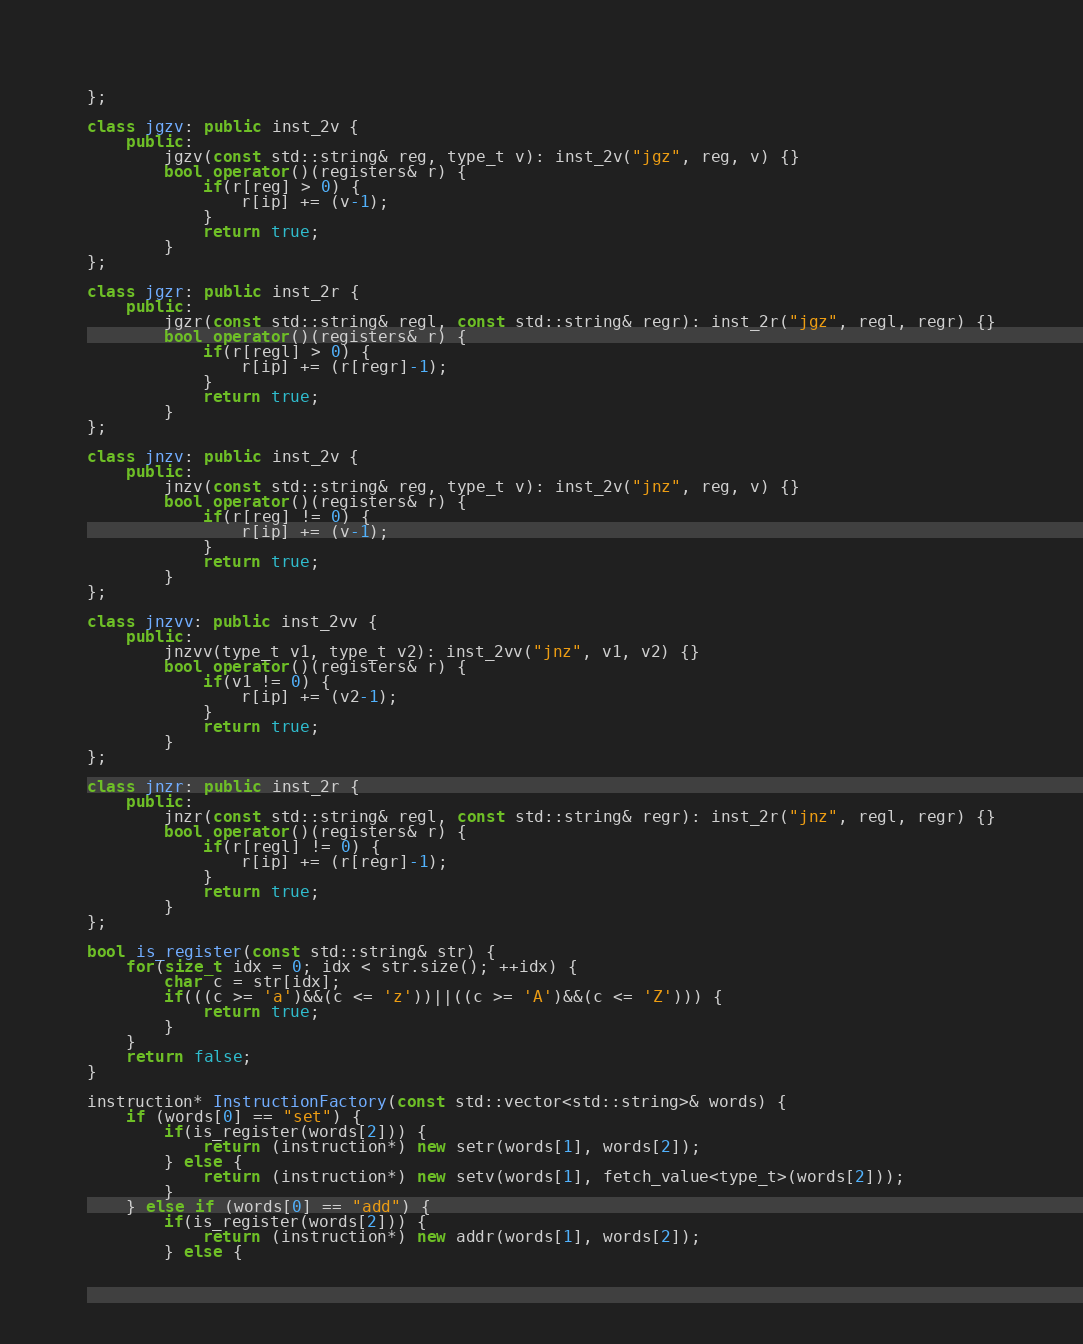Convert code to text. <code><loc_0><loc_0><loc_500><loc_500><_C++_>};

class jgzv: public inst_2v {
    public:
        jgzv(const std::string& reg, type_t v): inst_2v("jgz", reg, v) {}
        bool operator()(registers& r) {
            if(r[reg] > 0) {
                r[ip] += (v-1);
            }
            return true;
        }
};

class jgzr: public inst_2r {
    public:
        jgzr(const std::string& regl, const std::string& regr): inst_2r("jgz", regl, regr) {}
        bool operator()(registers& r) {
            if(r[regl] > 0) {
                r[ip] += (r[regr]-1);
            }
            return true;
        }
};

class jnzv: public inst_2v {
    public:
        jnzv(const std::string& reg, type_t v): inst_2v("jnz", reg, v) {}
        bool operator()(registers& r) {
            if(r[reg] != 0) {
                r[ip] += (v-1);
            }
            return true;
        }
};

class jnzvv: public inst_2vv {
    public:
        jnzvv(type_t v1, type_t v2): inst_2vv("jnz", v1, v2) {}
        bool operator()(registers& r) {
            if(v1 != 0) {
                r[ip] += (v2-1);
            }
            return true;
        }
};

class jnzr: public inst_2r {
    public:
        jnzr(const std::string& regl, const std::string& regr): inst_2r("jnz", regl, regr) {}
        bool operator()(registers& r) {
            if(r[regl] != 0) {
                r[ip] += (r[regr]-1);
            }
            return true;
        }
};

bool is_register(const std::string& str) {
    for(size_t idx = 0; idx < str.size(); ++idx) {
        char c = str[idx];
        if(((c >= 'a')&&(c <= 'z'))||((c >= 'A')&&(c <= 'Z'))) {
            return true;
        }
    }
    return false;
}

instruction* InstructionFactory(const std::vector<std::string>& words) {
    if (words[0] == "set") {
        if(is_register(words[2])) {
            return (instruction*) new setr(words[1], words[2]);
        } else {
            return (instruction*) new setv(words[1], fetch_value<type_t>(words[2]));
        }
    } else if (words[0] == "add") {
        if(is_register(words[2])) {
            return (instruction*) new addr(words[1], words[2]);
        } else {</code> 